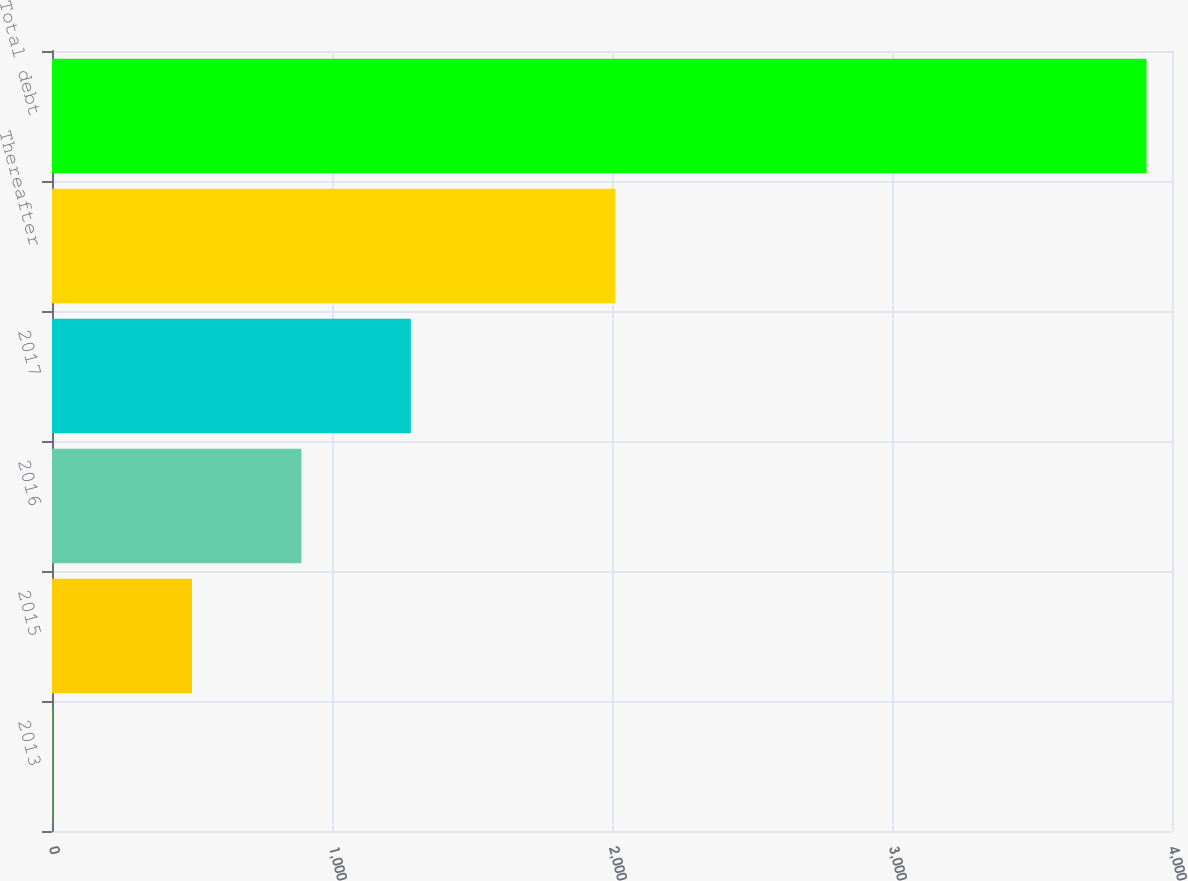Convert chart to OTSL. <chart><loc_0><loc_0><loc_500><loc_500><bar_chart><fcel>2013<fcel>2015<fcel>2016<fcel>2017<fcel>Thereafter<fcel>Total debt<nl><fcel>1<fcel>500<fcel>890.8<fcel>1281.6<fcel>2012<fcel>3909<nl></chart> 